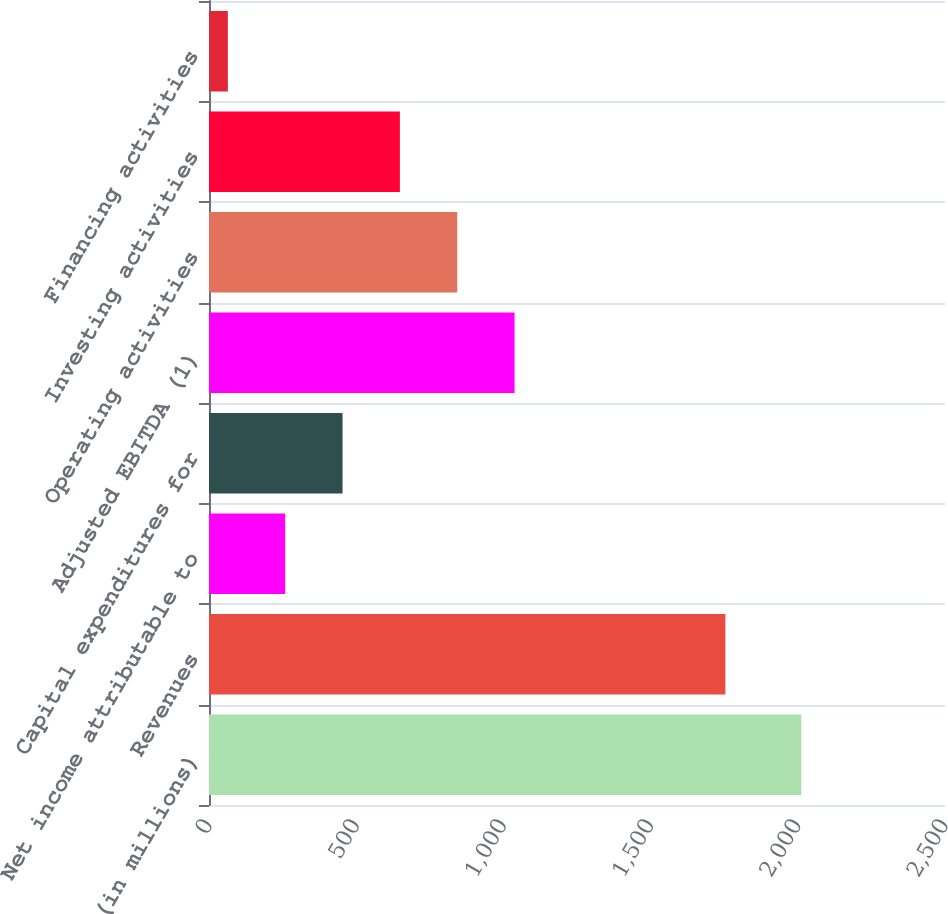<chart> <loc_0><loc_0><loc_500><loc_500><bar_chart><fcel>(in millions)<fcel>Revenues<fcel>Net income attributable to<fcel>Capital expenditures for<fcel>Adjusted EBITDA (1)<fcel>Operating activities<fcel>Investing activities<fcel>Financing activities<nl><fcel>2012<fcel>1754<fcel>258.8<fcel>453.6<fcel>1038<fcel>843.2<fcel>648.4<fcel>64<nl></chart> 